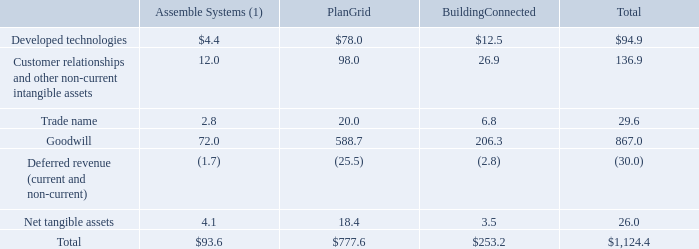Preliminary Purchase Price Allocation
For the Assemble Systems, PlanGrid, and BuildingConnected acquisitions that were accounted for as business combinations, Autodesk recorded the tangible and intangible assets acquired and liabilities assumed based on their estimated fair values at the date of acquisition. The fair values assigned to the identifiable intangible assets acquired were based on estimates and assumptions determined by management. Autodesk recorded the excess of consideration transferred over the aggregate fair values as goodwill. The goodwill recorded is primarily attributable to synergies expected to arise after the acquisition. There is no amount of goodwill that is deductible for U.S. income tax purposes.
The following table summarizes the fair value of the assets acquired and liabilities assumed by major class for the business combinations that were completed during the fiscal year ended January 31, 2019:
(1) During Q4 of fiscal 2019, Autodesk recorded a measurement period adjustment related to the valuation of the deferred tax liability associated with the Assemble Systems acquisition. This adjustment increased goodwill and reduced net tangible assets by $0.1 million.
For the three business combinations in fiscal 2019, the determination of estimated fair values of certain assets and liabilities is derived from estimated fair value assessments and assumptions by Autodesk. For PlanGrid and BuildingConnected, Autodesk's estimates and assumptions are subject to change within the measurement period (up to one year from the acquisition date). For the three business combinations in fiscal 2019, the tax impact of the acquisition is also subject to change within the measurement period. Different estimates and assumptions could result in different valuations assigned to the individual assets acquired and liabilities assumed, and the resulting amount of goodwill.
What is the goodwill recorded primarily attributable to? The goodwill recorded is primarily attributable to synergies expected to arise after the acquisition. How is the determination of estimated fair values of certain assets and liabilities for the three business combinations in fiscal 2019 derived? For the three business combinations in fiscal 2019, the determination of estimated fair values of certain assets and liabilities is derived from estimated fair value assessments and assumptions by autodesk. What is the total amount of developed technologies?
Answer scale should be: million. $94.9. What is the total amount of net tangible assets for PlanGrid and BuildingConnected?
Answer scale should be: million. 18.4+3.5
Answer: 21.9. What is the total amount of developed technologies for Assemble Systems and Plan Grid?
Answer scale should be: million. 4.4+78
Answer: 82.4. How much does goodwill account for the total?
Answer scale should be: percent. 867/1,124.4
Answer: 77.11. 